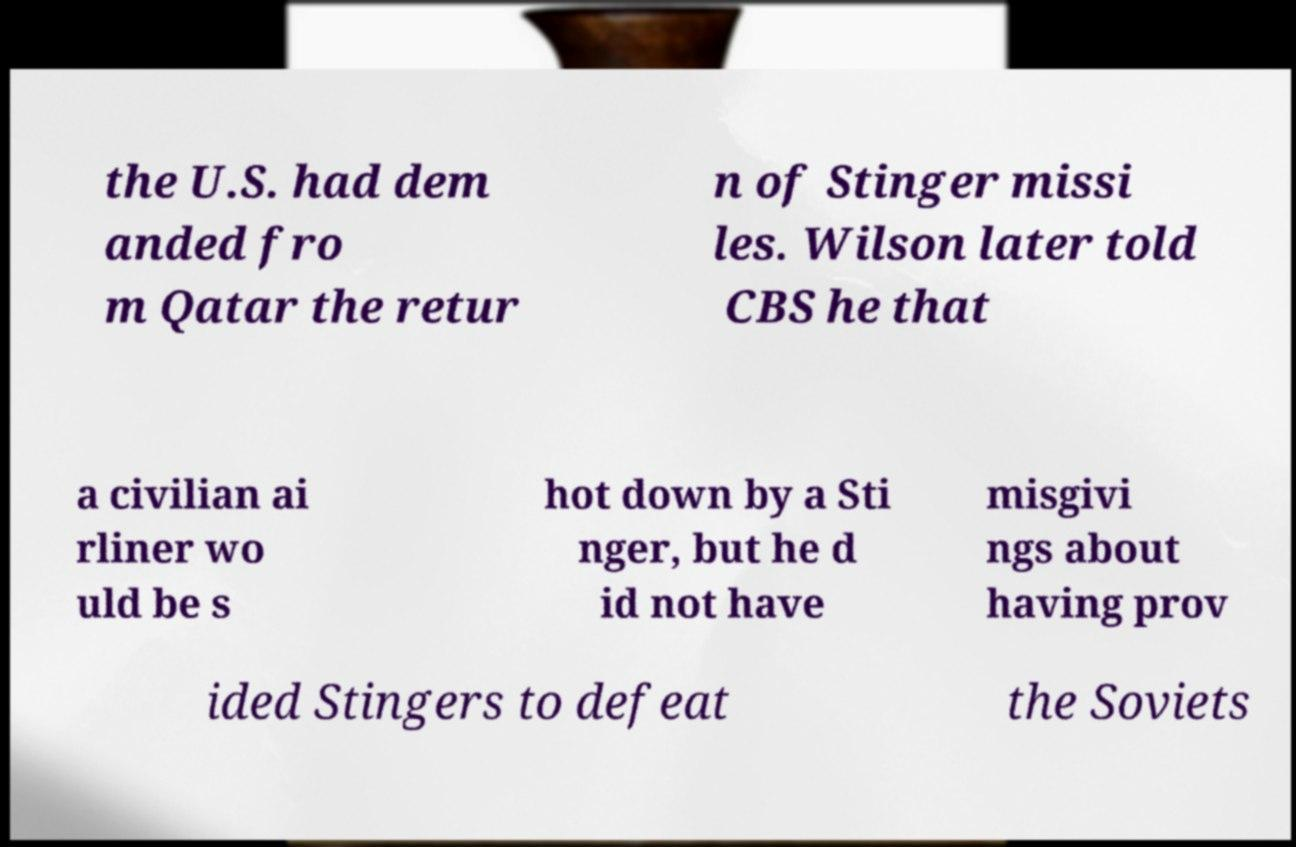Could you assist in decoding the text presented in this image and type it out clearly? the U.S. had dem anded fro m Qatar the retur n of Stinger missi les. Wilson later told CBS he that a civilian ai rliner wo uld be s hot down by a Sti nger, but he d id not have misgivi ngs about having prov ided Stingers to defeat the Soviets 